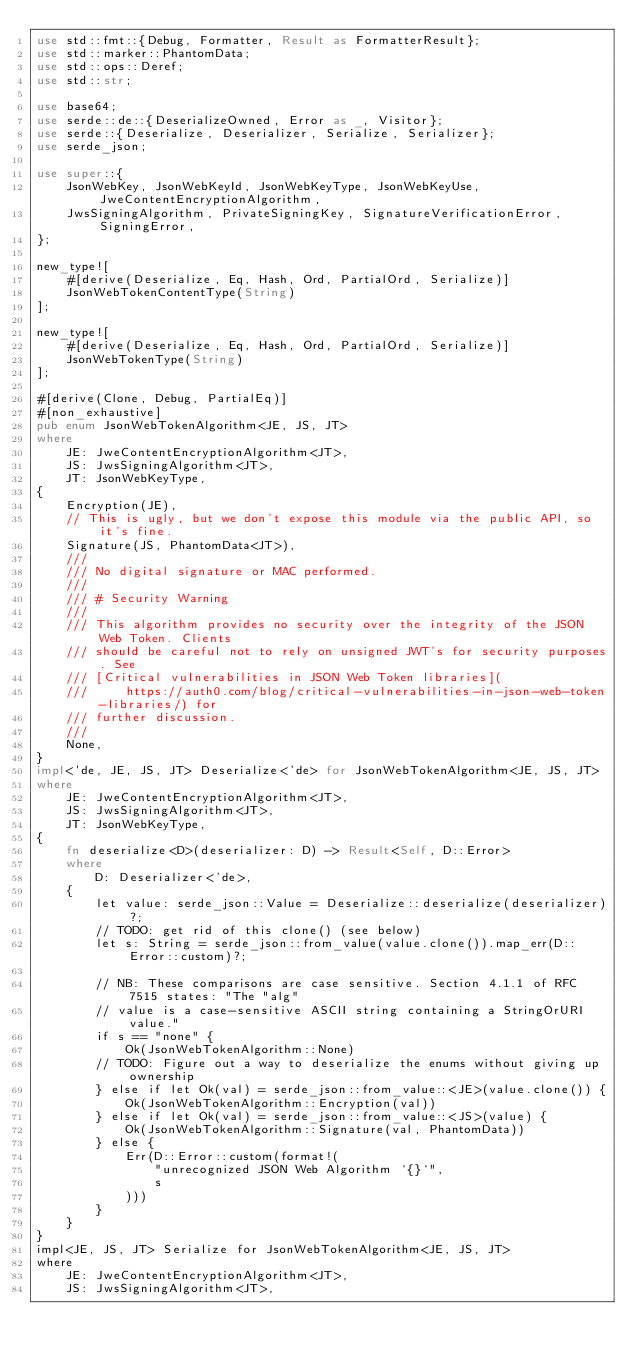<code> <loc_0><loc_0><loc_500><loc_500><_Rust_>use std::fmt::{Debug, Formatter, Result as FormatterResult};
use std::marker::PhantomData;
use std::ops::Deref;
use std::str;

use base64;
use serde::de::{DeserializeOwned, Error as _, Visitor};
use serde::{Deserialize, Deserializer, Serialize, Serializer};
use serde_json;

use super::{
    JsonWebKey, JsonWebKeyId, JsonWebKeyType, JsonWebKeyUse, JweContentEncryptionAlgorithm,
    JwsSigningAlgorithm, PrivateSigningKey, SignatureVerificationError, SigningError,
};

new_type![
    #[derive(Deserialize, Eq, Hash, Ord, PartialOrd, Serialize)]
    JsonWebTokenContentType(String)
];

new_type![
    #[derive(Deserialize, Eq, Hash, Ord, PartialOrd, Serialize)]
    JsonWebTokenType(String)
];

#[derive(Clone, Debug, PartialEq)]
#[non_exhaustive]
pub enum JsonWebTokenAlgorithm<JE, JS, JT>
where
    JE: JweContentEncryptionAlgorithm<JT>,
    JS: JwsSigningAlgorithm<JT>,
    JT: JsonWebKeyType,
{
    Encryption(JE),
    // This is ugly, but we don't expose this module via the public API, so it's fine.
    Signature(JS, PhantomData<JT>),
    ///
    /// No digital signature or MAC performed.
    ///
    /// # Security Warning
    ///
    /// This algorithm provides no security over the integrity of the JSON Web Token. Clients
    /// should be careful not to rely on unsigned JWT's for security purposes. See
    /// [Critical vulnerabilities in JSON Web Token libraries](
    ///     https://auth0.com/blog/critical-vulnerabilities-in-json-web-token-libraries/) for
    /// further discussion.
    ///
    None,
}
impl<'de, JE, JS, JT> Deserialize<'de> for JsonWebTokenAlgorithm<JE, JS, JT>
where
    JE: JweContentEncryptionAlgorithm<JT>,
    JS: JwsSigningAlgorithm<JT>,
    JT: JsonWebKeyType,
{
    fn deserialize<D>(deserializer: D) -> Result<Self, D::Error>
    where
        D: Deserializer<'de>,
    {
        let value: serde_json::Value = Deserialize::deserialize(deserializer)?;
        // TODO: get rid of this clone() (see below)
        let s: String = serde_json::from_value(value.clone()).map_err(D::Error::custom)?;

        // NB: These comparisons are case sensitive. Section 4.1.1 of RFC 7515 states: "The "alg"
        // value is a case-sensitive ASCII string containing a StringOrURI value."
        if s == "none" {
            Ok(JsonWebTokenAlgorithm::None)
        // TODO: Figure out a way to deserialize the enums without giving up ownership
        } else if let Ok(val) = serde_json::from_value::<JE>(value.clone()) {
            Ok(JsonWebTokenAlgorithm::Encryption(val))
        } else if let Ok(val) = serde_json::from_value::<JS>(value) {
            Ok(JsonWebTokenAlgorithm::Signature(val, PhantomData))
        } else {
            Err(D::Error::custom(format!(
                "unrecognized JSON Web Algorithm `{}`",
                s
            )))
        }
    }
}
impl<JE, JS, JT> Serialize for JsonWebTokenAlgorithm<JE, JS, JT>
where
    JE: JweContentEncryptionAlgorithm<JT>,
    JS: JwsSigningAlgorithm<JT>,</code> 